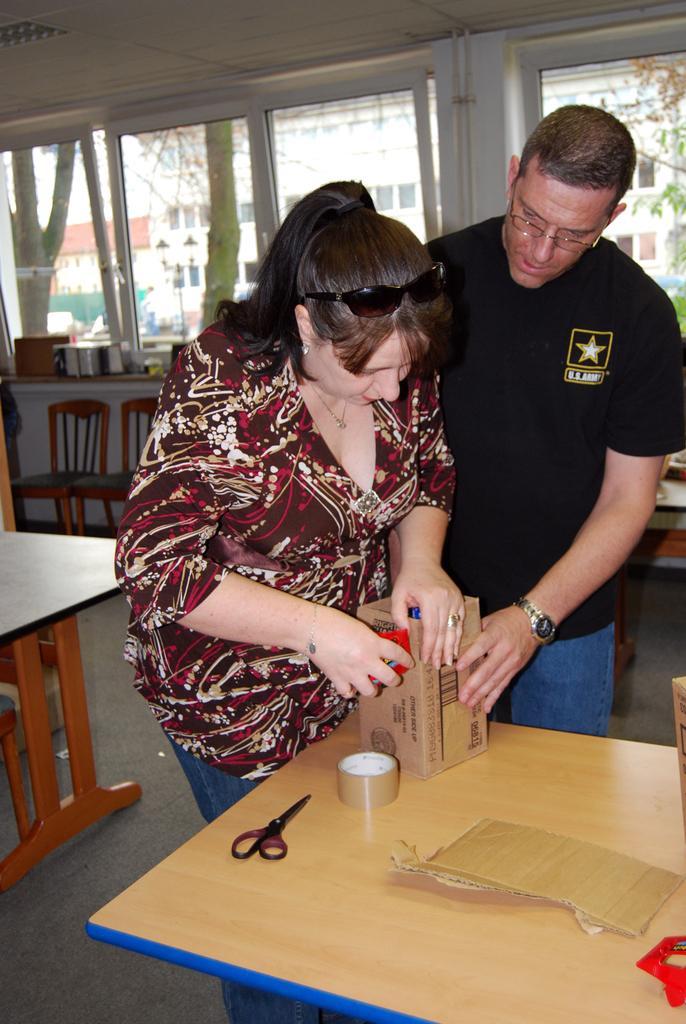Can you describe this image briefly? In the center of the image we can see a man and a lady standing and opening a box which is placed before them. At the bottom there are tables and we can see a scissor, tape, cardboard and some object placed on the table. In the background there are chairs and windows. 